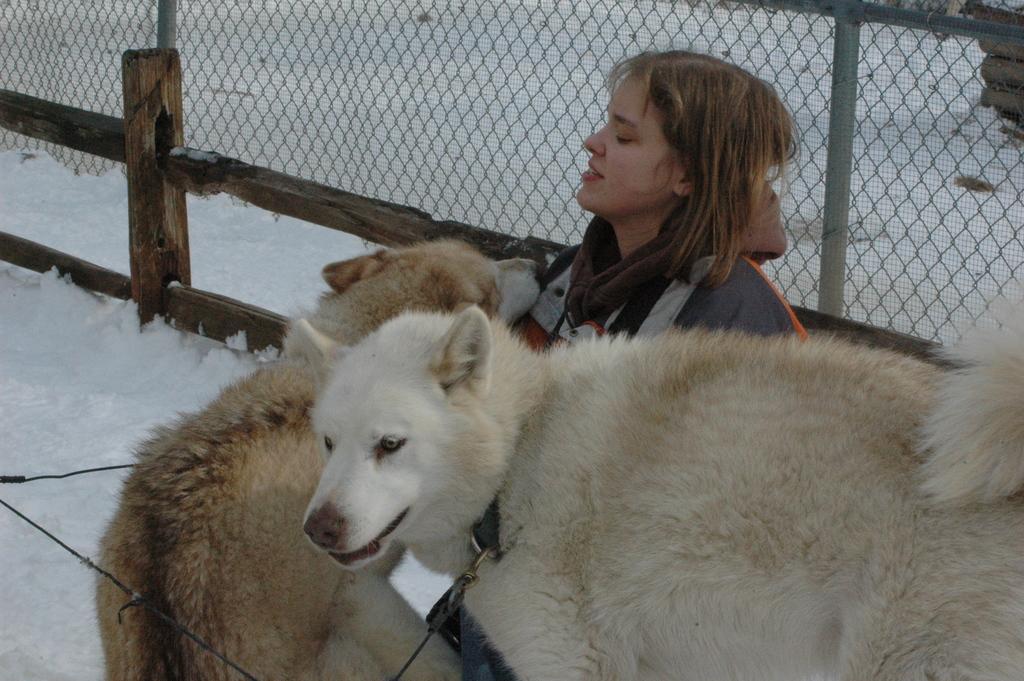Can you describe this image briefly? In the foreground of this image, there are two dogs and a woman wearing an over coat is sitting on the snow surface. In the background, we can see a fencing and the snow. 